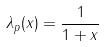<formula> <loc_0><loc_0><loc_500><loc_500>\lambda _ { p } ( x ) = \frac { 1 } { 1 + x }</formula> 